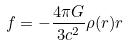Convert formula to latex. <formula><loc_0><loc_0><loc_500><loc_500>f = - \frac { 4 \pi G } { 3 c ^ { 2 } } \rho ( r ) r</formula> 